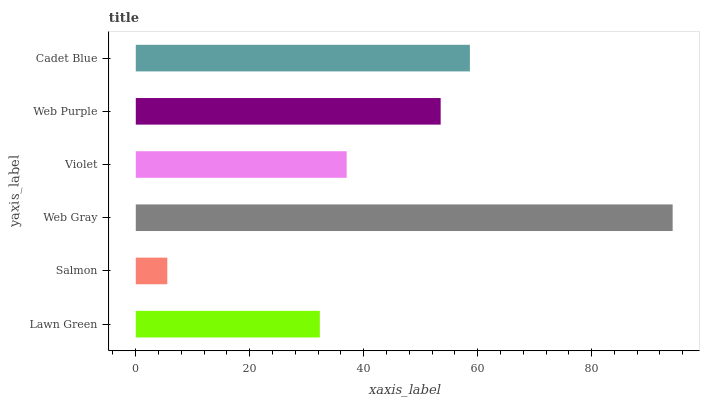Is Salmon the minimum?
Answer yes or no. Yes. Is Web Gray the maximum?
Answer yes or no. Yes. Is Web Gray the minimum?
Answer yes or no. No. Is Salmon the maximum?
Answer yes or no. No. Is Web Gray greater than Salmon?
Answer yes or no. Yes. Is Salmon less than Web Gray?
Answer yes or no. Yes. Is Salmon greater than Web Gray?
Answer yes or no. No. Is Web Gray less than Salmon?
Answer yes or no. No. Is Web Purple the high median?
Answer yes or no. Yes. Is Violet the low median?
Answer yes or no. Yes. Is Salmon the high median?
Answer yes or no. No. Is Web Gray the low median?
Answer yes or no. No. 